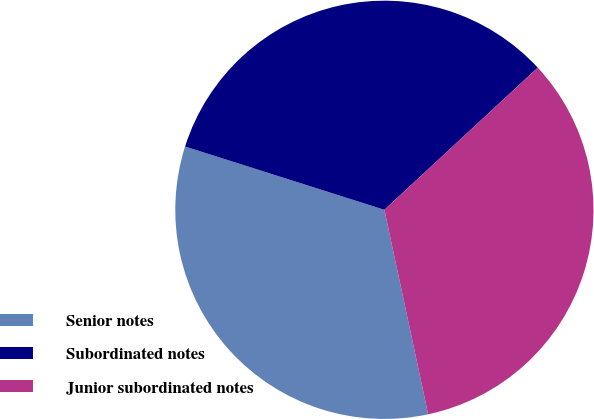Convert chart. <chart><loc_0><loc_0><loc_500><loc_500><pie_chart><fcel>Senior notes<fcel>Subordinated notes<fcel>Junior subordinated notes<nl><fcel>33.25%<fcel>33.21%<fcel>33.54%<nl></chart> 